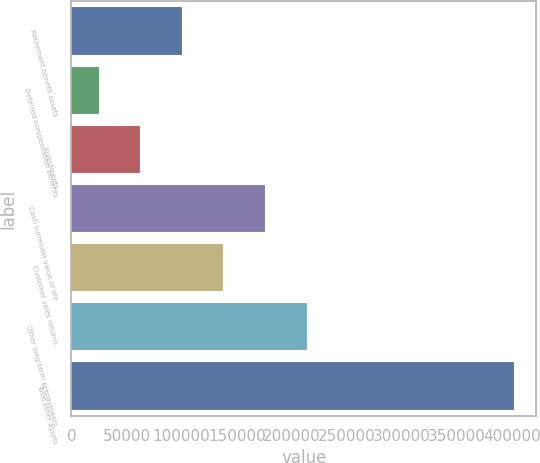Convert chart. <chart><loc_0><loc_0><loc_500><loc_500><bar_chart><fcel>Retirement benefit assets<fcel>Deferred compensation benefits<fcel>Investments<fcel>Cash surrender value of life<fcel>Customer sales returns<fcel>Other long-term prepayments<fcel>Total other assets<nl><fcel>100318<fcel>24939<fcel>62628.5<fcel>175697<fcel>138008<fcel>213386<fcel>401834<nl></chart> 